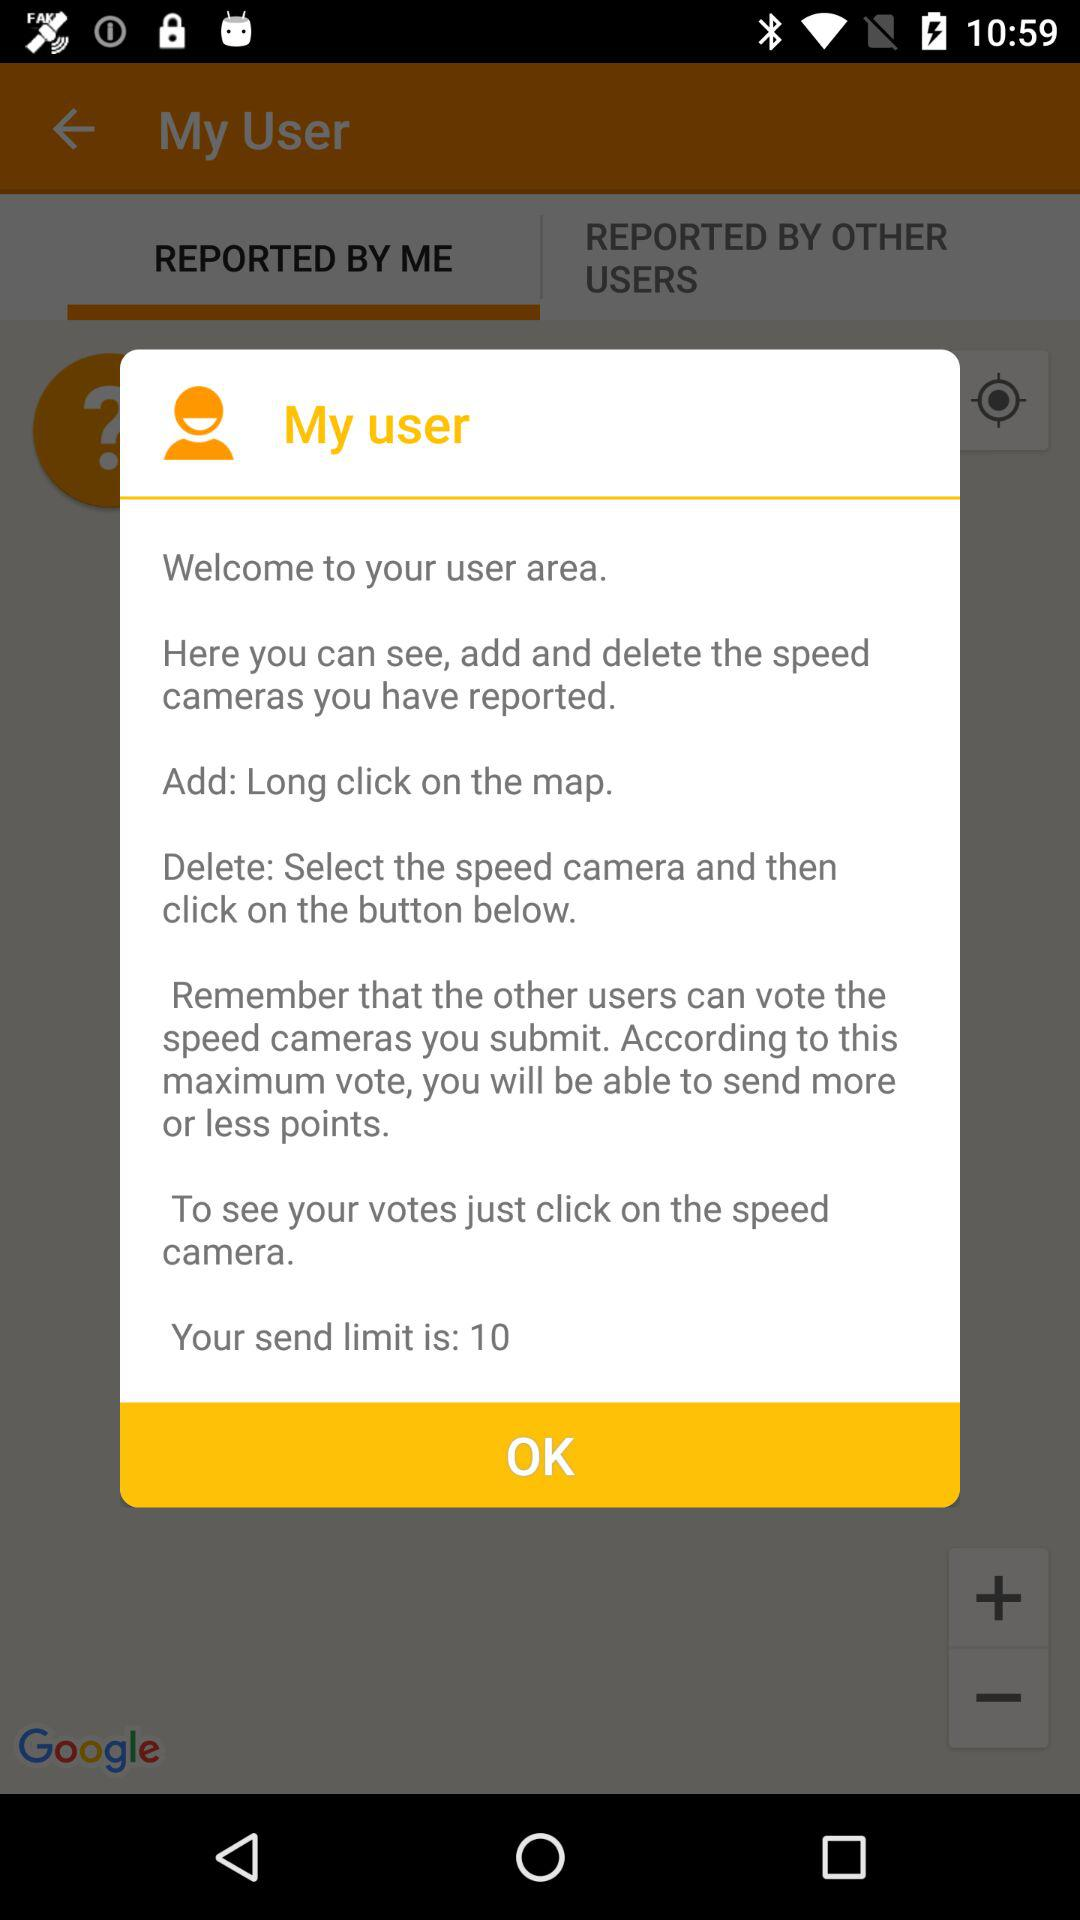How can we add a speed camera? You can long click on the map to add a speed camera. 